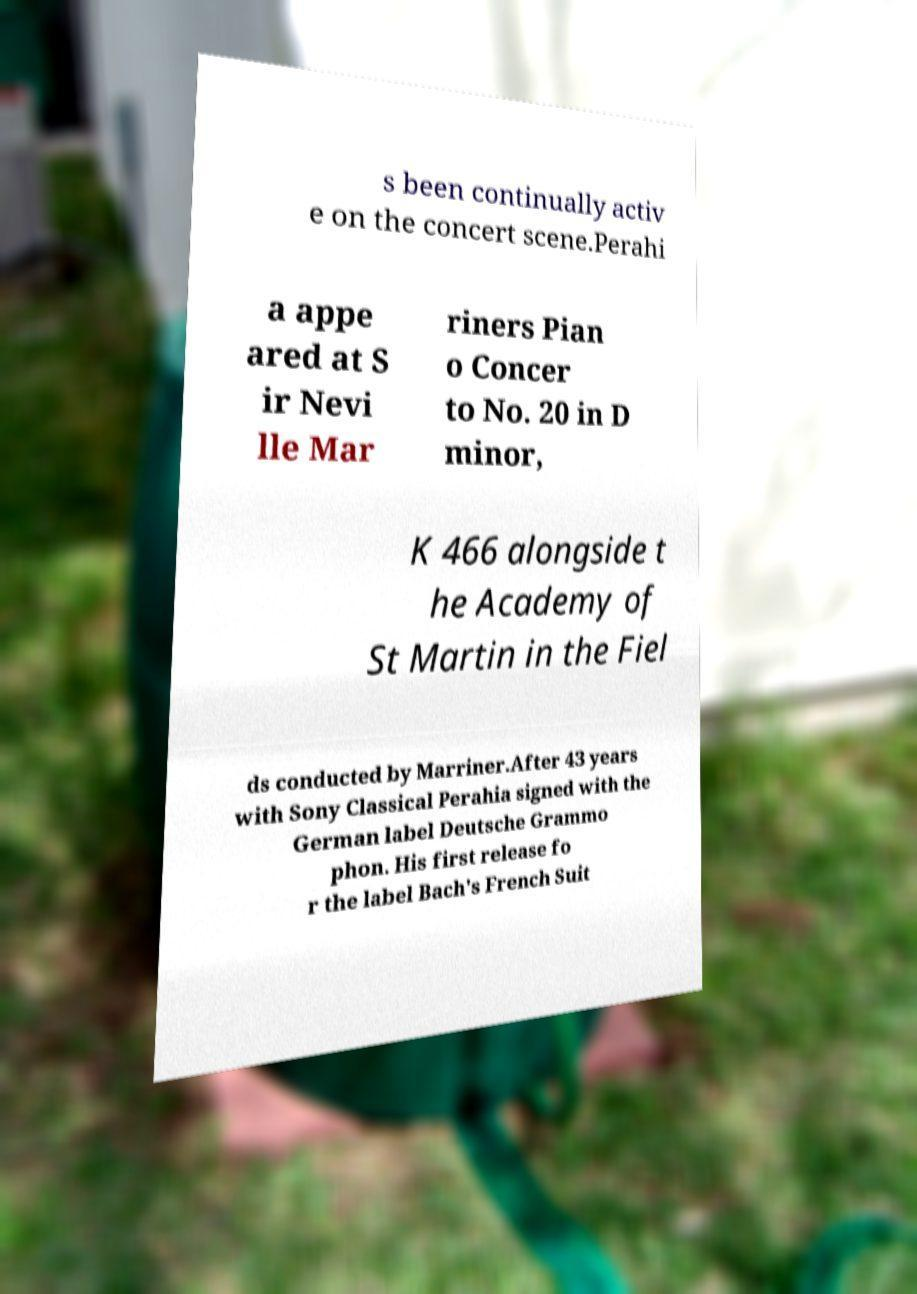Can you read and provide the text displayed in the image?This photo seems to have some interesting text. Can you extract and type it out for me? s been continually activ e on the concert scene.Perahi a appe ared at S ir Nevi lle Mar riners Pian o Concer to No. 20 in D minor, K 466 alongside t he Academy of St Martin in the Fiel ds conducted by Marriner.After 43 years with Sony Classical Perahia signed with the German label Deutsche Grammo phon. His first release fo r the label Bach's French Suit 